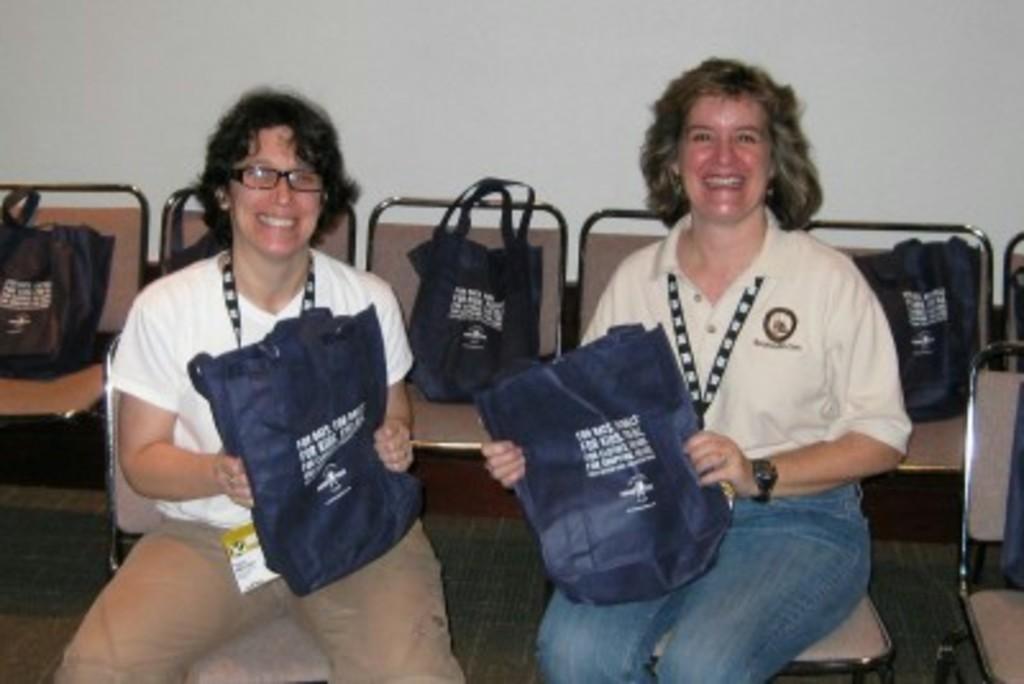Please provide a concise description of this image. In this image there are two women sitting and two of them are holding some bags, and in the background there are chairs. On the cars there are some bags, at the bottom there is floor and at the top of the image there is wall. 